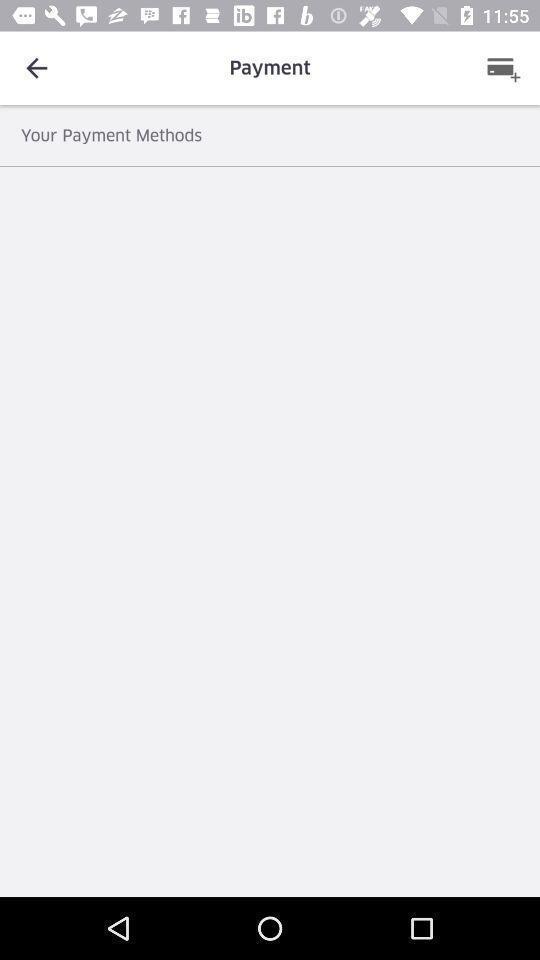Provide a description of this screenshot. Screen showing the blank page in payments. 